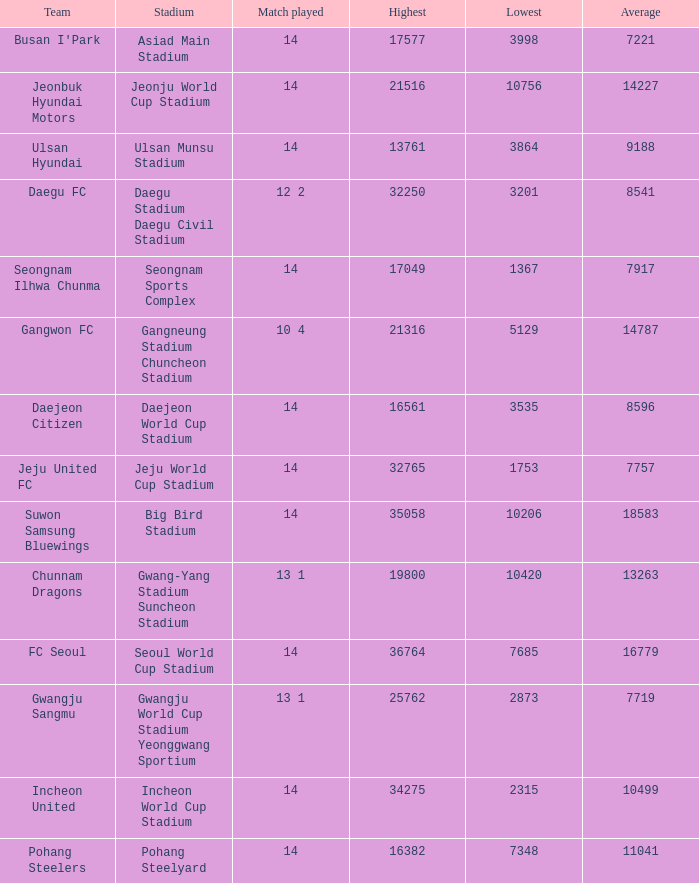What is the highest when pohang steelers is the team? 16382.0. 